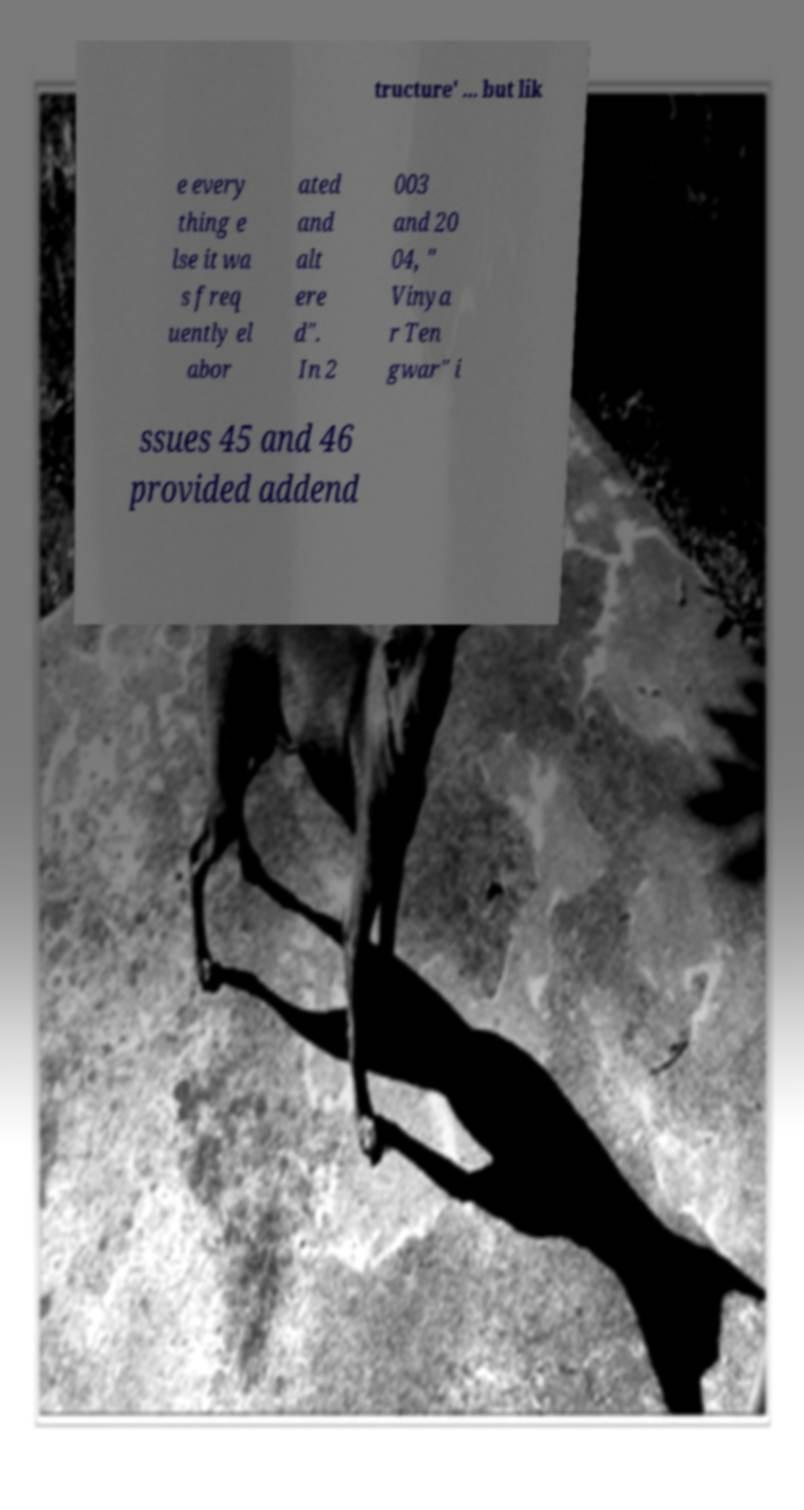I need the written content from this picture converted into text. Can you do that? tructure' ... but lik e every thing e lse it wa s freq uently el abor ated and alt ere d". In 2 003 and 20 04, " Vinya r Ten gwar" i ssues 45 and 46 provided addend 